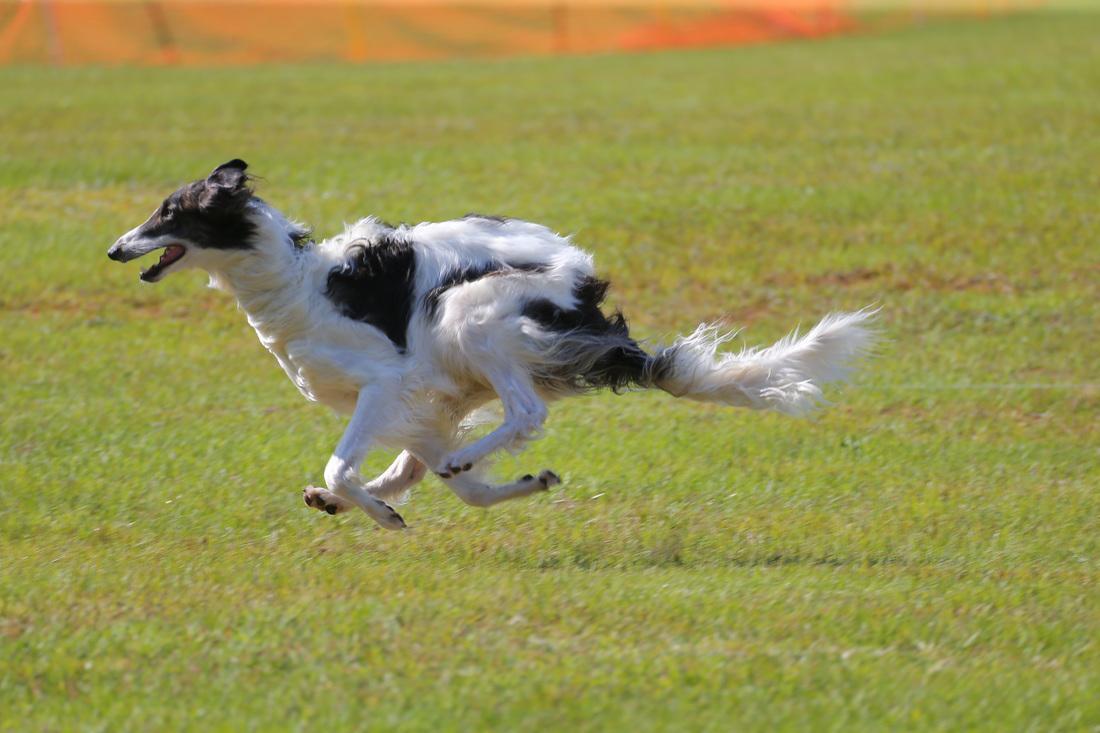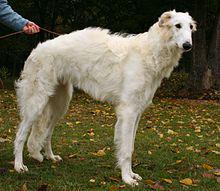The first image is the image on the left, the second image is the image on the right. Given the left and right images, does the statement "The dog in the image on the right is running across the grass to the right side." hold true? Answer yes or no. No. The first image is the image on the left, the second image is the image on the right. Analyze the images presented: Is the assertion "In total, at least two dogs are bounding across a field with front paws off the ground." valid? Answer yes or no. No. 